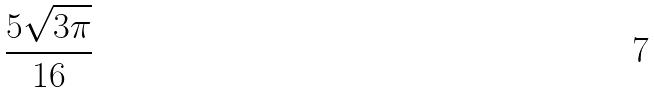<formula> <loc_0><loc_0><loc_500><loc_500>\frac { 5 \sqrt { 3 \pi } } { 1 6 }</formula> 